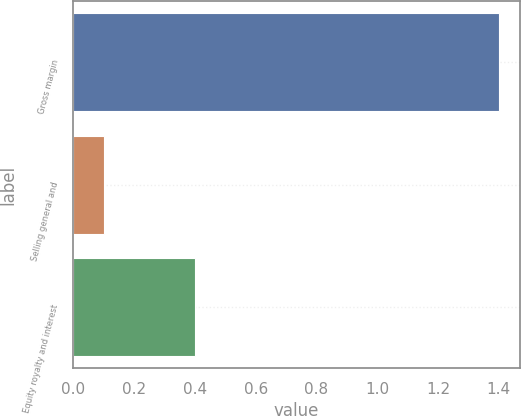<chart> <loc_0><loc_0><loc_500><loc_500><bar_chart><fcel>Gross margin<fcel>Selling general and<fcel>Equity royalty and interest<nl><fcel>1.4<fcel>0.1<fcel>0.4<nl></chart> 